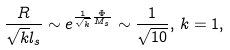Convert formula to latex. <formula><loc_0><loc_0><loc_500><loc_500>\frac { R } { \sqrt { k } l _ { s } } \sim e ^ { \frac { 1 } { \sqrt { k } } \frac { \Phi } { M _ { s } } } \sim \frac { 1 } { \sqrt { 1 0 } } , \, k = 1 ,</formula> 